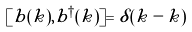Convert formula to latex. <formula><loc_0><loc_0><loc_500><loc_500>[ b ( k ) , b ^ { \dagger } ( \tilde { k } ) ] = \delta ( k - \tilde { k } )</formula> 